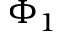<formula> <loc_0><loc_0><loc_500><loc_500>\Phi _ { 1 }</formula> 